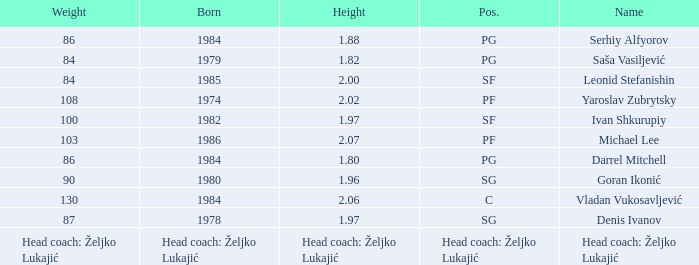What was the weight of Serhiy Alfyorov? 86.0. 